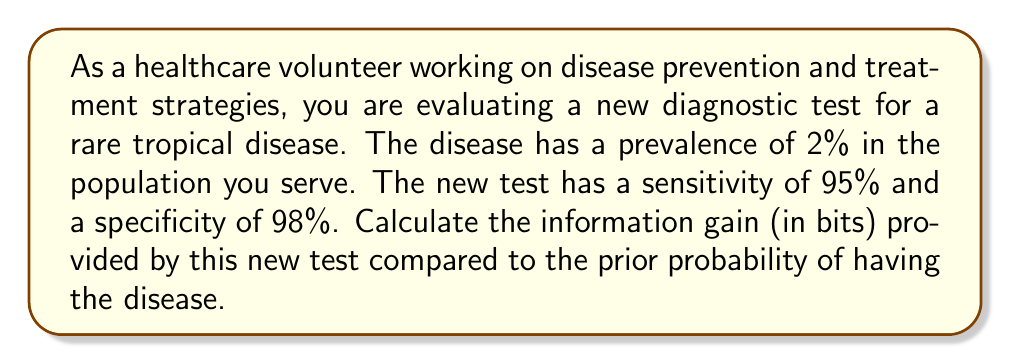Could you help me with this problem? To calculate the information gain from the new diagnostic test, we need to follow these steps:

1. Calculate the prior entropy (uncertainty before the test):
   $H(D) = -p(D) \log_2 p(D) - p(\neg D) \log_2 p(\neg D)$
   Where $D$ represents having the disease, and $\neg D$ represents not having the disease.

2. Calculate the posterior entropy (uncertainty after the test):
   $H(D|T) = p(T^+) H(D|T^+) + p(T^-) H(D|T^-)$
   Where $T^+$ represents a positive test result, and $T^-$ represents a negative test result.

3. Calculate the information gain:
   $IG = H(D) - H(D|T)$

Step 1: Prior Entropy
$p(D) = 0.02$ (prevalence of the disease)
$p(\neg D) = 1 - p(D) = 0.98$

$$\begin{aligned}
H(D) &= -0.02 \log_2 0.02 - 0.98 \log_2 0.98 \\
&= 0.1414 + 0.0291 \\
&= 0.1705 \text{ bits}
\end{aligned}$$

Step 2: Posterior Entropy
First, we need to calculate $p(T^+)$, $p(T^-)$, $p(D|T^+)$, and $p(D|T^-)$ using Bayes' theorem:

$p(T^+) = p(T^+|D)p(D) + p(T^+|\neg D)p(\neg D) = 0.95 \cdot 0.02 + 0.02 \cdot 0.98 = 0.0386$
$p(T^-) = 1 - p(T^+) = 0.9614$

$p(D|T^+) = \frac{p(T^+|D)p(D)}{p(T^+)} = \frac{0.95 \cdot 0.02}{0.0386} = 0.4922$
$p(D|T^-) = \frac{p(T^-|D)p(D)}{p(T^-)} = \frac{0.05 \cdot 0.02}{0.9614} = 0.0010$

Now we can calculate $H(D|T^+)$ and $H(D|T^-)$:

$$\begin{aligned}
H(D|T^+) &= -0.4922 \log_2 0.4922 - 0.5078 \log_2 0.5078 = 0.9998 \text{ bits} \\
H(D|T^-) &= -0.0010 \log_2 0.0010 - 0.9990 \log_2 0.9990 = 0.0141 \text{ bits}
\end{aligned}$$

Now we can calculate the posterior entropy:

$$\begin{aligned}
H(D|T) &= 0.0386 \cdot 0.9998 + 0.9614 \cdot 0.0141 \\
&= 0.0386 + 0.0136 \\
&= 0.0522 \text{ bits}
\end{aligned}$$

Step 3: Information Gain
$$\begin{aligned}
IG &= H(D) - H(D|T) \\
&= 0.1705 - 0.0522 \\
&= 0.1183 \text{ bits}
\end{aligned}$$
Answer: The information gain provided by the new diagnostic test is 0.1183 bits. 